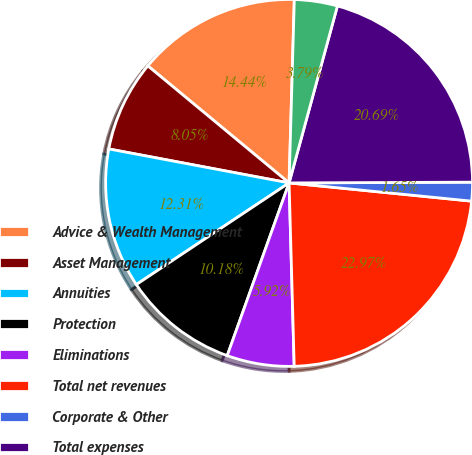Convert chart to OTSL. <chart><loc_0><loc_0><loc_500><loc_500><pie_chart><fcel>Advice & Wealth Management<fcel>Asset Management<fcel>Annuities<fcel>Protection<fcel>Eliminations<fcel>Total net revenues<fcel>Corporate & Other<fcel>Total expenses<fcel>Pretax income<nl><fcel>14.44%<fcel>8.05%<fcel>12.31%<fcel>10.18%<fcel>5.92%<fcel>22.97%<fcel>1.65%<fcel>20.69%<fcel>3.79%<nl></chart> 